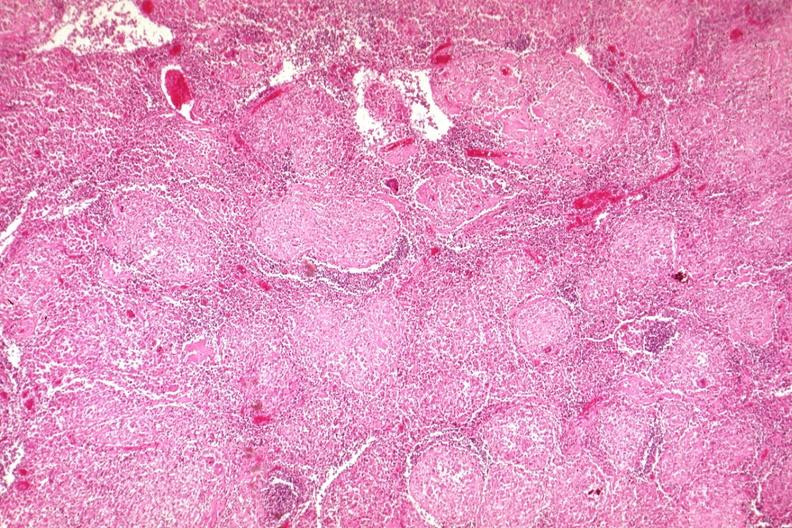what does this image show?
Answer the question using a single word or phrase. Typical granulomas 